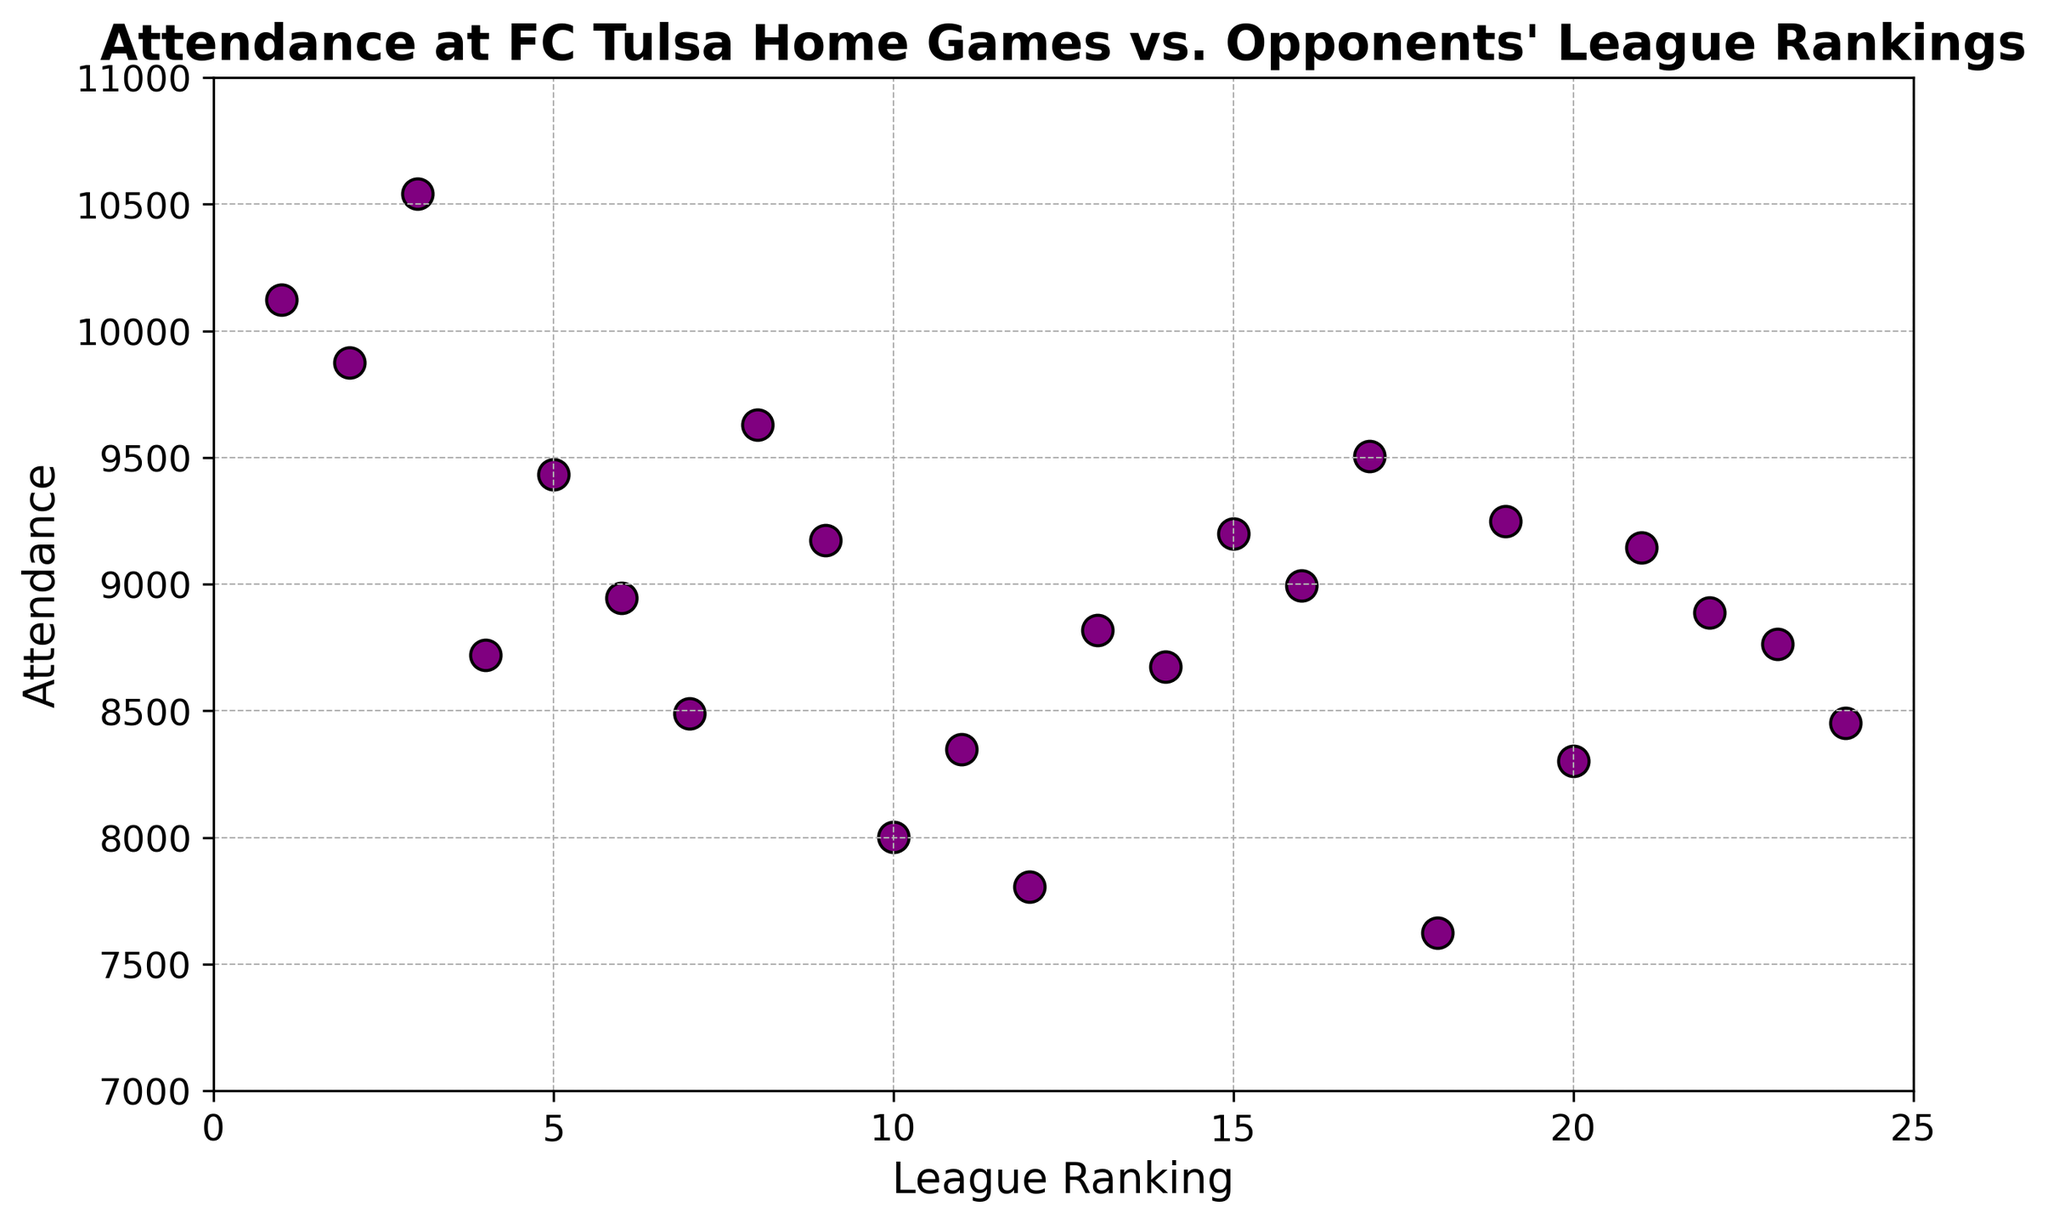How many opponents have attendance greater than 9000? To determine how many opponents drew more than 9000 attendees, look for data points above the 9000 mark on the y-axis. Count these points.
Answer: 11 Which opponent had the highest attendance at FC Tulsa home games, and what was that attendance? The data point farthest up on the y-axis represents the highest attendance. Identify the opponent corresponding to this data point and its associated value.
Answer: Team C, 10543 What's the average attendance against opponents ranked in the top 5? Find the attendance values for opponents ranked 1 to 5, sum them up, and divide by the number of these values (5). (10123 + 9876 + 10543 + 8721 + 9432) / 5 = 9659
Answer: 9659 How does attendance compare between opponents ranked 10 and 11? Locate the data points for league rankings 10 and 11 on the x-axis, and compare the y-values (attendance). For ranking 10, attendance is 8002; for ranking 11, attendance is 8348.
Answer: Attendance for ranking 11 is higher What is the median attendance for all FC Tulsa home games? To find the median, list all attendance values in ascending order and pick the middle value. With 24 data points, the median is the average of the 12th and 13th values. Sorted: (7623, 7805, 8002, 8301, 8348, 8451, 8490, 8674, 8721, 8765, 8820, 8888, 8945, 8994, 9145, 9174, 9201, 9250, 9432, 9506, 9631, 9876, 10123, 10543). Median is (8888+8945)/2 = 8916.5
Answer: 8916.5 How does attendance against the lowest ranked opponent (Team X) compare with the attendance against the highest ranked opponent (Team A)? Find the attendance numbers for Team X (lowest ranking) and Team A (highest ranking) and compare them. Team X has an attendance of 8451 and Team A has 10123.
Answer: Attendance for Team A is larger Which team had the lowest attendance at FC Tulsa home games, and what was that attendance? Locate the data point farthest down on the y-axis to find the lowest attendance, and then identify the opponent corresponding to this point.
Answer: Team R, 7623 Is there a trend in attendance based on opponents' league ranking? Look for any visible pattern in the scatter plot. There does not appear to be a clear upward or downward trend based on visual inspection; points are relatively scattered without a strong correlation.
Answer: No clear trend How many games had attendance between 8500 and 9500? Count the data points with y-values (attendance) in the range from 8500 to 9500.
Answer: 9 What's the difference in attendance between the games against the highest-ranked and the lowest-ranked opponents? Calculate the difference between the highest (Team C, 10543) and the lowest (Team R, 7623) attendance values. 10543 - 7623 = 2920
Answer: 2920 